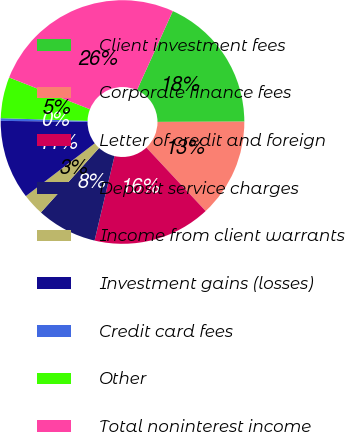<chart> <loc_0><loc_0><loc_500><loc_500><pie_chart><fcel>Client investment fees<fcel>Corporate finance fees<fcel>Letter of credit and foreign<fcel>Deposit service charges<fcel>Income from client warrants<fcel>Investment gains (losses)<fcel>Credit card fees<fcel>Other<fcel>Total noninterest income<nl><fcel>18.18%<fcel>13.09%<fcel>15.64%<fcel>8.0%<fcel>2.91%<fcel>10.55%<fcel>0.36%<fcel>5.45%<fcel>25.82%<nl></chart> 